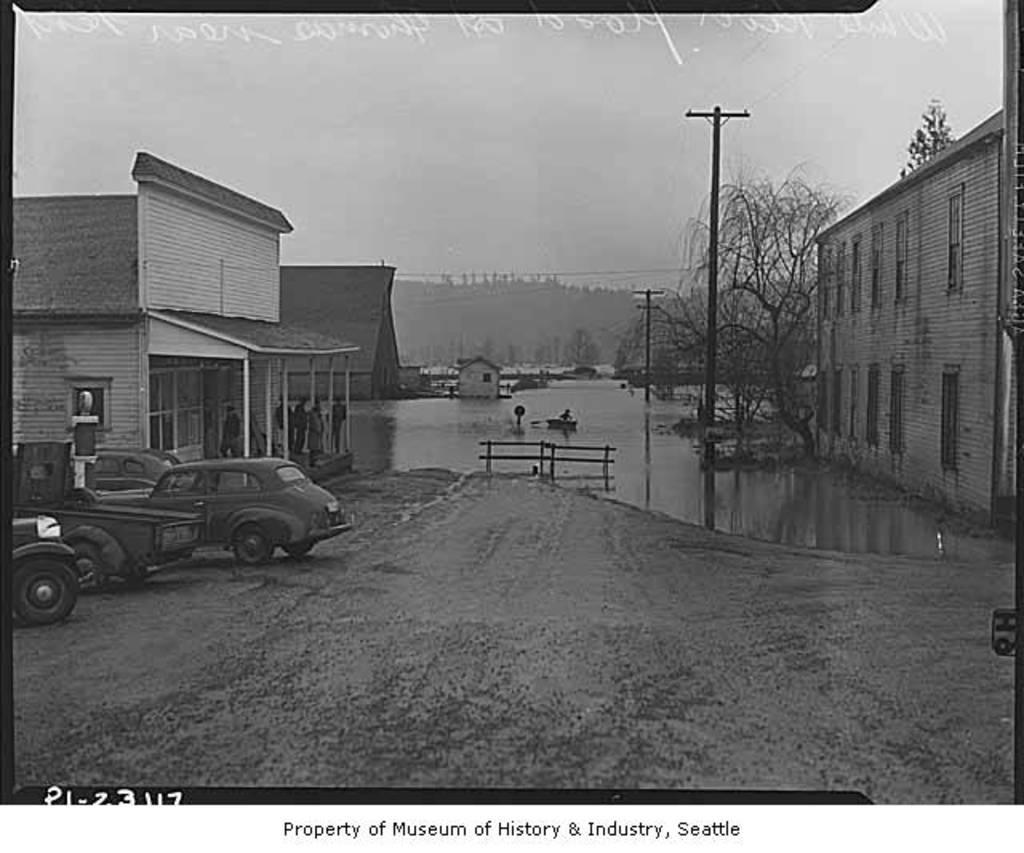What type of structures can be seen in the image? There are buildings in the image. What object is also visible in the image? There is a pot in the image. What activity is taking place in the image? Vehicles are being parked in the image. How many frogs can be seen hopping around the pot in the image? There are no frogs present in the image. What type of store is located near the buildings in the image? There is no store mentioned or visible in the image. 